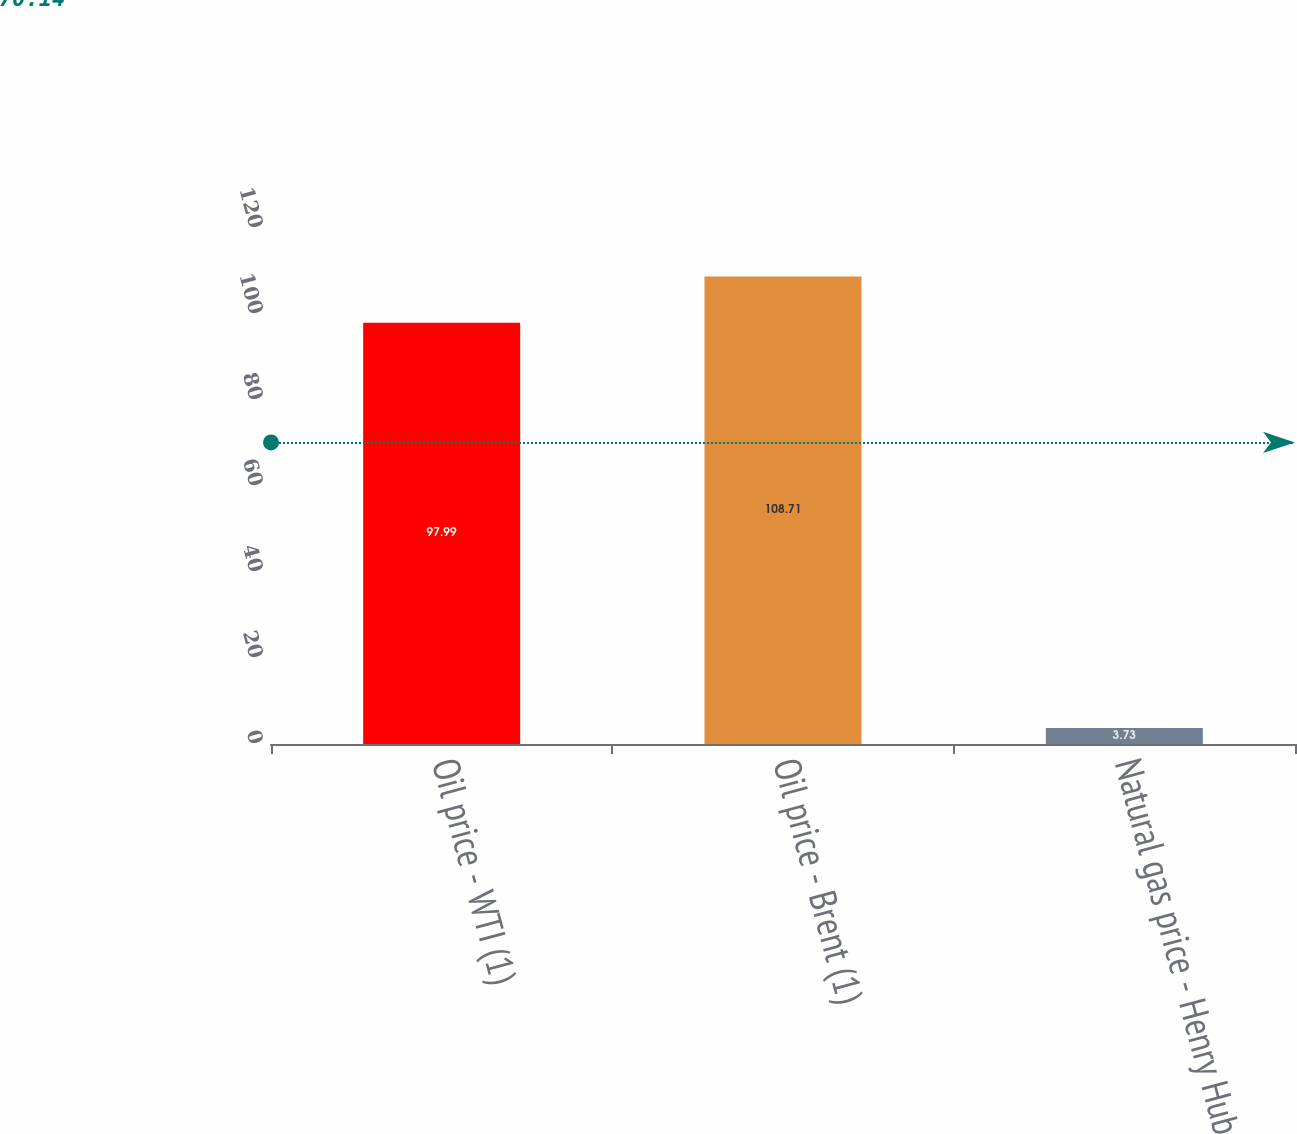<chart> <loc_0><loc_0><loc_500><loc_500><bar_chart><fcel>Oil price - WTI (1)<fcel>Oil price - Brent (1)<fcel>Natural gas price - Henry Hub<nl><fcel>97.99<fcel>108.71<fcel>3.73<nl></chart> 